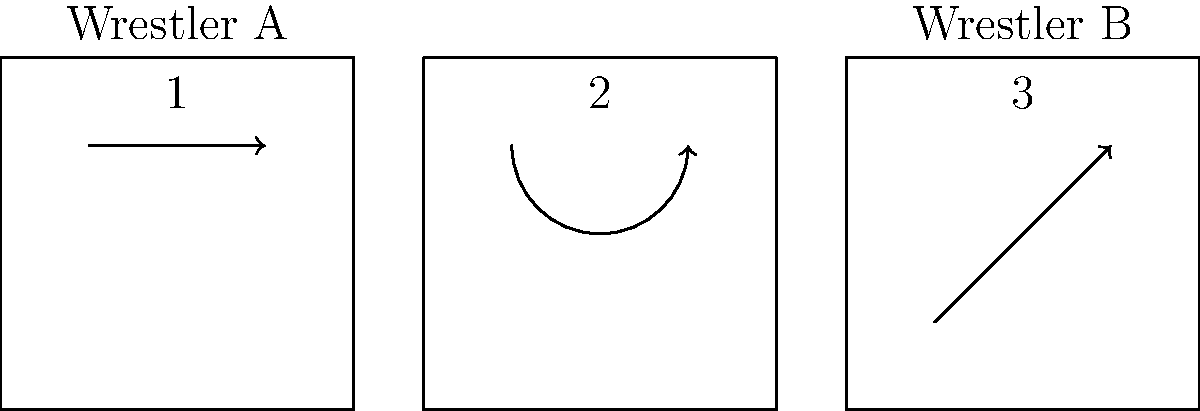Based on the sequential frames depicting a wrestling move, which classic maneuver is being executed by Wrestler A on Wrestler B? To identify the wrestling move, let's analyze the sequence of frames:

1. Frame 1: We see an arrow moving horizontally, suggesting Wrestler A is approaching Wrestler B.
2. Frame 2: The curved arrow indicates a circular motion, likely Wrestler A grabbing Wrestler B and beginning a rotation.
3. Frame 3: The diagonal arrow pointing upward shows the completion of the move, with Wrestler B being lifted and thrown.

This sequence of movements is characteristic of a classic wrestling move called the "Suplex." In a suplex:
- The attacking wrestler approaches the opponent (Frame 1)
- Grasps the opponent, often around the waist (implied between Frames 1 and 2)
- Lifts and rotates the opponent (Frame 2)
- Bridges backward, slamming the opponent onto their back (Frame 3)

The suplex is known for its dramatic execution and requires significant strength and timing, making it a favorite among wrestlers and fans alike.
Answer: Suplex 